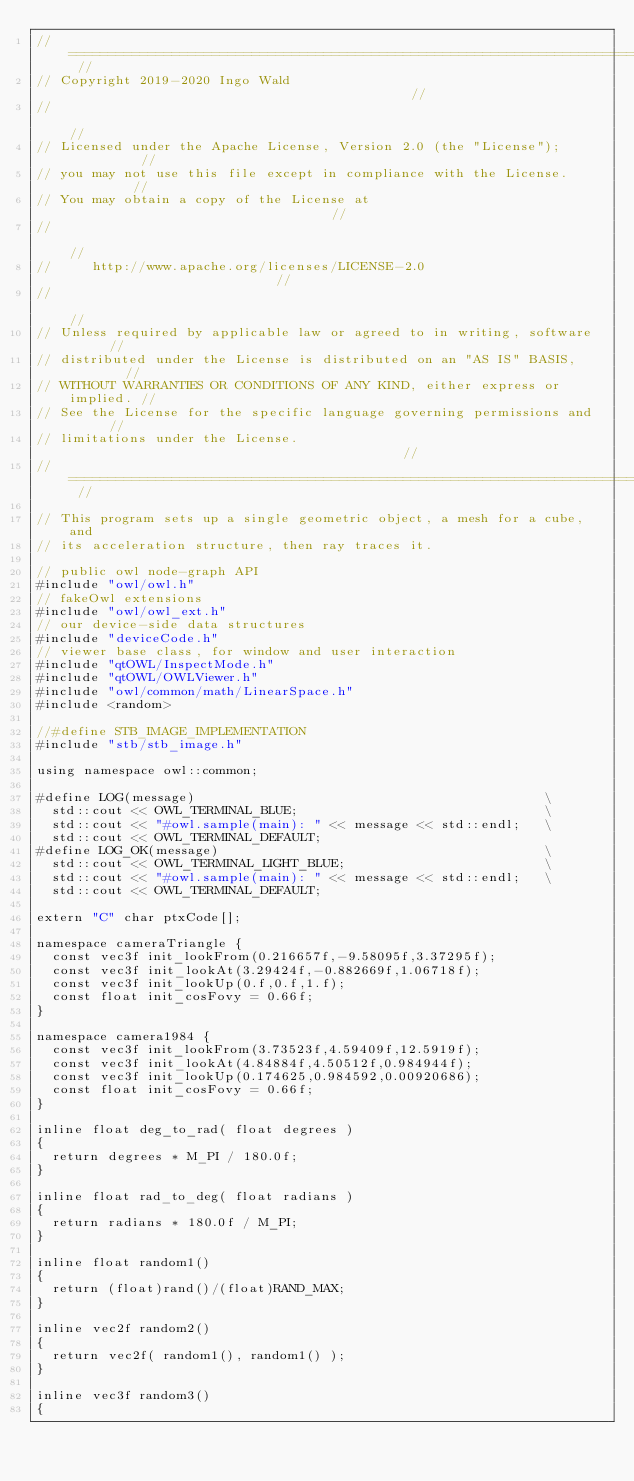<code> <loc_0><loc_0><loc_500><loc_500><_C++_>// ======================================================================== //
// Copyright 2019-2020 Ingo Wald                                            //
//                                                                          //
// Licensed under the Apache License, Version 2.0 (the "License");          //
// you may not use this file except in compliance with the License.         //
// You may obtain a copy of the License at                                  //
//                                                                          //
//     http://www.apache.org/licenses/LICENSE-2.0                           //
//                                                                          //
// Unless required by applicable law or agreed to in writing, software      //
// distributed under the License is distributed on an "AS IS" BASIS,        //
// WITHOUT WARRANTIES OR CONDITIONS OF ANY KIND, either express or implied. //
// See the License for the specific language governing permissions and      //
// limitations under the License.                                           //
// ======================================================================== //

// This program sets up a single geometric object, a mesh for a cube, and
// its acceleration structure, then ray traces it.

// public owl node-graph API
#include "owl/owl.h"
// fakeOwl extensions
#include "owl/owl_ext.h"
// our device-side data structures
#include "deviceCode.h"
// viewer base class, for window and user interaction
#include "qtOWL/InspectMode.h"
#include "qtOWL/OWLViewer.h"
#include "owl/common/math/LinearSpace.h"
#include <random>

//#define STB_IMAGE_IMPLEMENTATION
#include "stb/stb_image.h"

using namespace owl::common;

#define LOG(message)                                            \
  std::cout << OWL_TERMINAL_BLUE;                               \
  std::cout << "#owl.sample(main): " << message << std::endl;   \
  std::cout << OWL_TERMINAL_DEFAULT;
#define LOG_OK(message)                                         \
  std::cout << OWL_TERMINAL_LIGHT_BLUE;                         \
  std::cout << "#owl.sample(main): " << message << std::endl;   \
  std::cout << OWL_TERMINAL_DEFAULT;

extern "C" char ptxCode[];

namespace cameraTriangle {
  const vec3f init_lookFrom(0.216657f,-9.58095f,3.37295f);
  const vec3f init_lookAt(3.29424f,-0.882669f,1.06718f);
  const vec3f init_lookUp(0.f,0.f,1.f);
  const float init_cosFovy = 0.66f;
}

namespace camera1984 {
  const vec3f init_lookFrom(3.73523f,4.59409f,12.5919f);
  const vec3f init_lookAt(4.84884f,4.50512f,0.984944f);
  const vec3f init_lookUp(0.174625,0.984592,0.00920686);
  const float init_cosFovy = 0.66f;
}

inline float deg_to_rad( float degrees )
{
  return degrees * M_PI / 180.0f;
}

inline float rad_to_deg( float radians )
{
  return radians * 180.0f / M_PI;
}

inline float random1()
{
  return (float)rand()/(float)RAND_MAX;
}

inline vec2f random2()
{
  return vec2f( random1(), random1() );
}

inline vec3f random3()
{</code> 